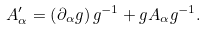Convert formula to latex. <formula><loc_0><loc_0><loc_500><loc_500>A _ { \alpha } ^ { \prime } = \left ( \partial _ { \alpha } g \right ) g ^ { - 1 } + g A _ { \alpha } g ^ { - 1 } .</formula> 